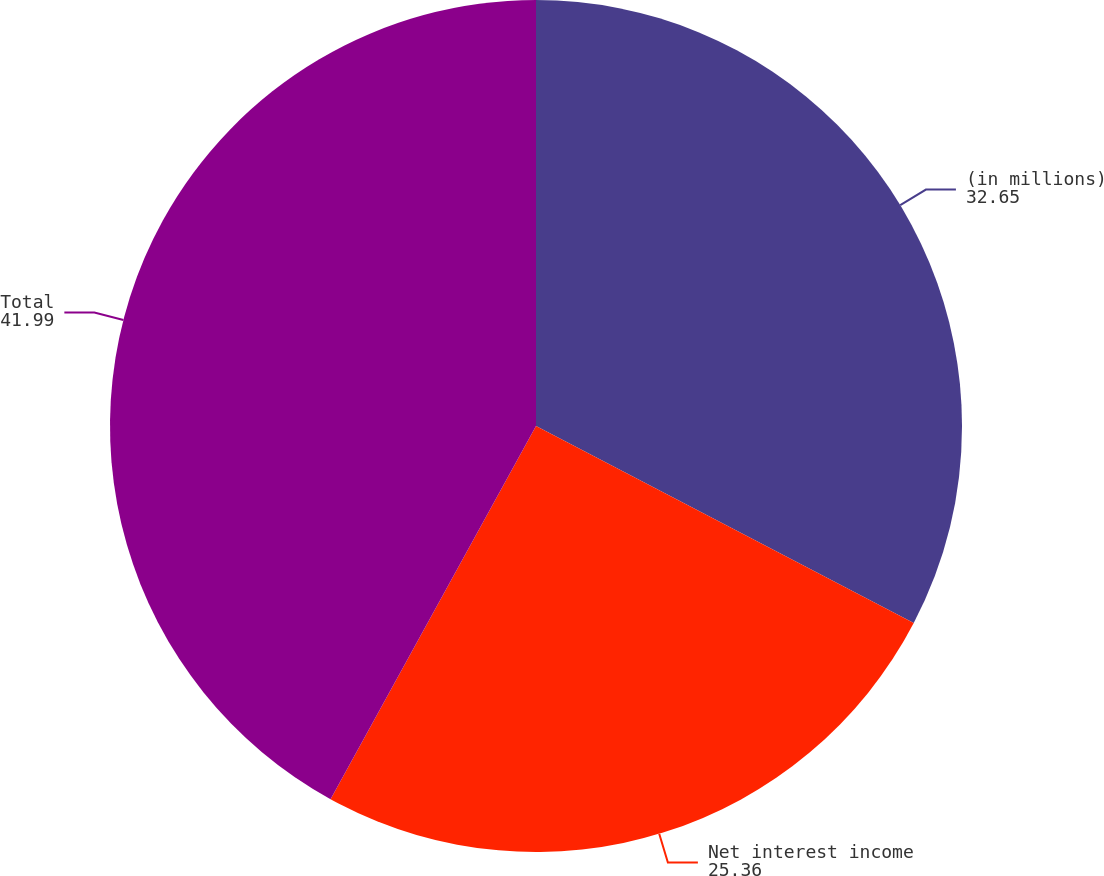Convert chart. <chart><loc_0><loc_0><loc_500><loc_500><pie_chart><fcel>(in millions)<fcel>Net interest income<fcel>Total<nl><fcel>32.65%<fcel>25.36%<fcel>41.99%<nl></chart> 